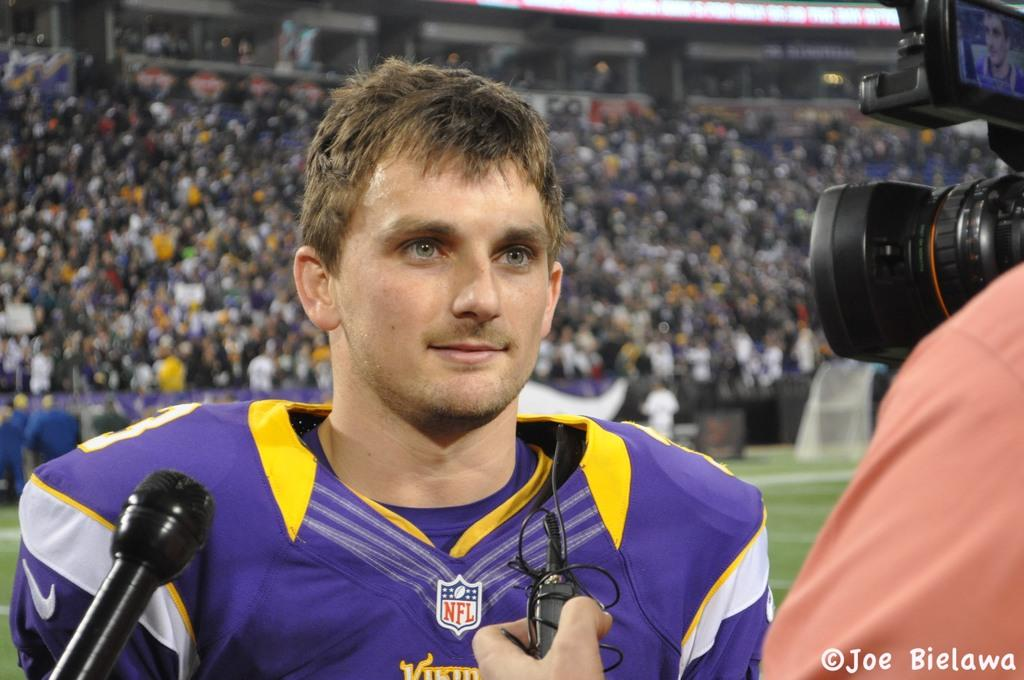Provide a one-sentence caption for the provided image. A Vikings player with an NFL logo on his shirt talks to the reporter. 